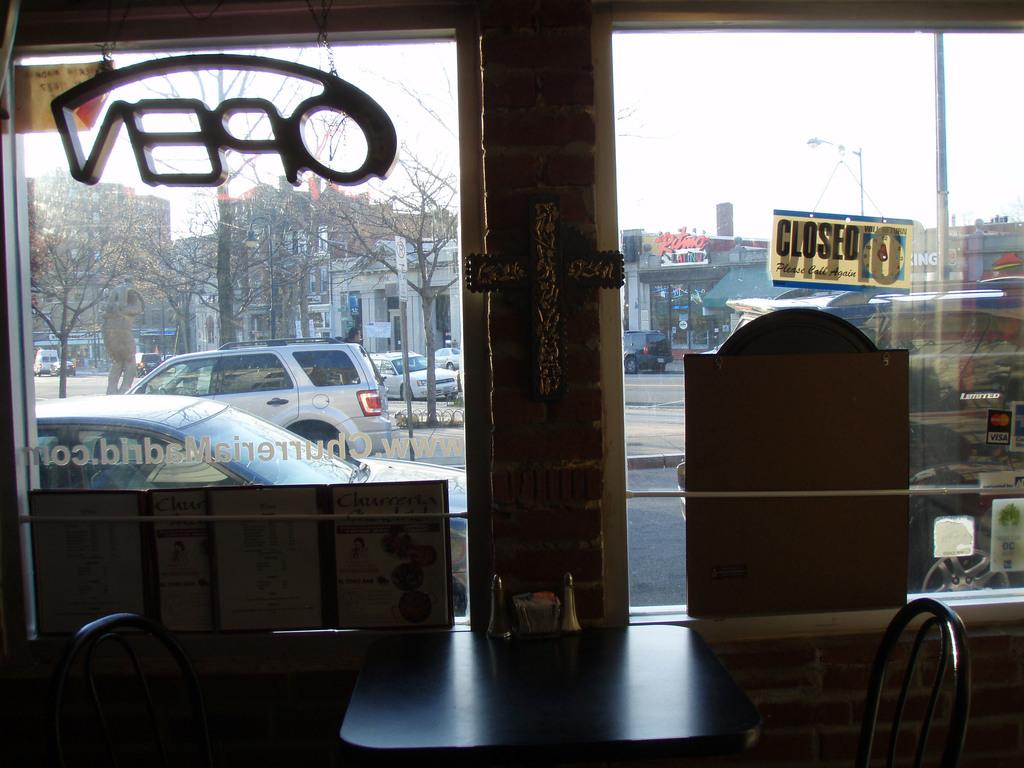What type of structure is visible in the image? There is a building in the image. What is a feature of the building that can be seen in the image? There is a door in the image. What furniture is present in the image? There is a table and a chair in the image. How many other buildings can be seen in the background of the image? The background of the image includes three buildings. What type of vehicle is visible in the background of the image? There is a car in the background of the image. What other object can be seen in the background of the image? There is a pole and a light in the background of the image. What part of the natural environment is visible in the background of the image? The sky is visible in the background of the image. How many snakes are crawling on the table in the image? There are no snakes present in the image; the table is empty. 